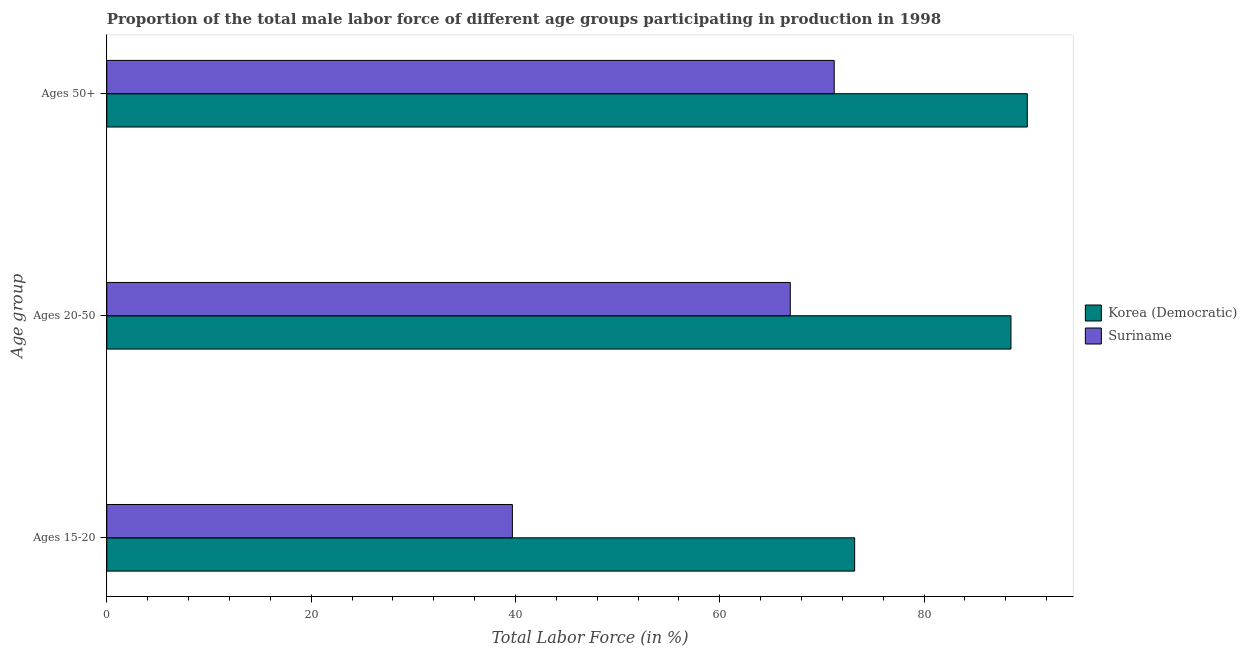Are the number of bars per tick equal to the number of legend labels?
Ensure brevity in your answer.  Yes. Are the number of bars on each tick of the Y-axis equal?
Your answer should be very brief. Yes. How many bars are there on the 3rd tick from the bottom?
Make the answer very short. 2. What is the label of the 2nd group of bars from the top?
Give a very brief answer. Ages 20-50. What is the percentage of male labor force above age 50 in Suriname?
Provide a short and direct response. 71.2. Across all countries, what is the maximum percentage of male labor force within the age group 20-50?
Keep it short and to the point. 88.5. Across all countries, what is the minimum percentage of male labor force within the age group 20-50?
Your answer should be very brief. 66.9. In which country was the percentage of male labor force above age 50 maximum?
Your answer should be compact. Korea (Democratic). In which country was the percentage of male labor force within the age group 15-20 minimum?
Provide a short and direct response. Suriname. What is the total percentage of male labor force within the age group 15-20 in the graph?
Keep it short and to the point. 112.9. What is the difference between the percentage of male labor force within the age group 15-20 in Korea (Democratic) and that in Suriname?
Your response must be concise. 33.5. What is the difference between the percentage of male labor force above age 50 in Suriname and the percentage of male labor force within the age group 20-50 in Korea (Democratic)?
Your answer should be very brief. -17.3. What is the average percentage of male labor force within the age group 15-20 per country?
Provide a succinct answer. 56.45. What is the difference between the percentage of male labor force within the age group 15-20 and percentage of male labor force within the age group 20-50 in Suriname?
Offer a very short reply. -27.2. What is the ratio of the percentage of male labor force above age 50 in Korea (Democratic) to that in Suriname?
Offer a very short reply. 1.27. Is the percentage of male labor force within the age group 15-20 in Suriname less than that in Korea (Democratic)?
Offer a terse response. Yes. What is the difference between the highest and the second highest percentage of male labor force above age 50?
Offer a very short reply. 18.9. What is the difference between the highest and the lowest percentage of male labor force within the age group 15-20?
Ensure brevity in your answer.  33.5. What does the 1st bar from the top in Ages 15-20 represents?
Ensure brevity in your answer.  Suriname. What does the 1st bar from the bottom in Ages 50+ represents?
Provide a short and direct response. Korea (Democratic). How many bars are there?
Your answer should be compact. 6. Are all the bars in the graph horizontal?
Keep it short and to the point. Yes. How many countries are there in the graph?
Your answer should be compact. 2. Are the values on the major ticks of X-axis written in scientific E-notation?
Offer a very short reply. No. Where does the legend appear in the graph?
Keep it short and to the point. Center right. How many legend labels are there?
Your response must be concise. 2. What is the title of the graph?
Provide a short and direct response. Proportion of the total male labor force of different age groups participating in production in 1998. Does "Cuba" appear as one of the legend labels in the graph?
Ensure brevity in your answer.  No. What is the label or title of the X-axis?
Your answer should be very brief. Total Labor Force (in %). What is the label or title of the Y-axis?
Provide a succinct answer. Age group. What is the Total Labor Force (in %) of Korea (Democratic) in Ages 15-20?
Ensure brevity in your answer.  73.2. What is the Total Labor Force (in %) of Suriname in Ages 15-20?
Keep it short and to the point. 39.7. What is the Total Labor Force (in %) of Korea (Democratic) in Ages 20-50?
Offer a terse response. 88.5. What is the Total Labor Force (in %) in Suriname in Ages 20-50?
Give a very brief answer. 66.9. What is the Total Labor Force (in %) in Korea (Democratic) in Ages 50+?
Give a very brief answer. 90.1. What is the Total Labor Force (in %) of Suriname in Ages 50+?
Provide a succinct answer. 71.2. Across all Age group, what is the maximum Total Labor Force (in %) in Korea (Democratic)?
Your answer should be compact. 90.1. Across all Age group, what is the maximum Total Labor Force (in %) of Suriname?
Keep it short and to the point. 71.2. Across all Age group, what is the minimum Total Labor Force (in %) in Korea (Democratic)?
Your answer should be compact. 73.2. Across all Age group, what is the minimum Total Labor Force (in %) of Suriname?
Provide a succinct answer. 39.7. What is the total Total Labor Force (in %) of Korea (Democratic) in the graph?
Make the answer very short. 251.8. What is the total Total Labor Force (in %) in Suriname in the graph?
Keep it short and to the point. 177.8. What is the difference between the Total Labor Force (in %) in Korea (Democratic) in Ages 15-20 and that in Ages 20-50?
Give a very brief answer. -15.3. What is the difference between the Total Labor Force (in %) in Suriname in Ages 15-20 and that in Ages 20-50?
Offer a terse response. -27.2. What is the difference between the Total Labor Force (in %) of Korea (Democratic) in Ages 15-20 and that in Ages 50+?
Ensure brevity in your answer.  -16.9. What is the difference between the Total Labor Force (in %) in Suriname in Ages 15-20 and that in Ages 50+?
Your response must be concise. -31.5. What is the difference between the Total Labor Force (in %) in Korea (Democratic) in Ages 20-50 and that in Ages 50+?
Provide a short and direct response. -1.6. What is the difference between the Total Labor Force (in %) in Suriname in Ages 20-50 and that in Ages 50+?
Provide a short and direct response. -4.3. What is the difference between the Total Labor Force (in %) in Korea (Democratic) in Ages 15-20 and the Total Labor Force (in %) in Suriname in Ages 50+?
Keep it short and to the point. 2. What is the difference between the Total Labor Force (in %) in Korea (Democratic) in Ages 20-50 and the Total Labor Force (in %) in Suriname in Ages 50+?
Ensure brevity in your answer.  17.3. What is the average Total Labor Force (in %) of Korea (Democratic) per Age group?
Your answer should be very brief. 83.93. What is the average Total Labor Force (in %) in Suriname per Age group?
Keep it short and to the point. 59.27. What is the difference between the Total Labor Force (in %) of Korea (Democratic) and Total Labor Force (in %) of Suriname in Ages 15-20?
Offer a terse response. 33.5. What is the difference between the Total Labor Force (in %) in Korea (Democratic) and Total Labor Force (in %) in Suriname in Ages 20-50?
Offer a very short reply. 21.6. What is the ratio of the Total Labor Force (in %) of Korea (Democratic) in Ages 15-20 to that in Ages 20-50?
Your answer should be very brief. 0.83. What is the ratio of the Total Labor Force (in %) of Suriname in Ages 15-20 to that in Ages 20-50?
Ensure brevity in your answer.  0.59. What is the ratio of the Total Labor Force (in %) in Korea (Democratic) in Ages 15-20 to that in Ages 50+?
Provide a short and direct response. 0.81. What is the ratio of the Total Labor Force (in %) of Suriname in Ages 15-20 to that in Ages 50+?
Keep it short and to the point. 0.56. What is the ratio of the Total Labor Force (in %) of Korea (Democratic) in Ages 20-50 to that in Ages 50+?
Your response must be concise. 0.98. What is the ratio of the Total Labor Force (in %) of Suriname in Ages 20-50 to that in Ages 50+?
Ensure brevity in your answer.  0.94. What is the difference between the highest and the lowest Total Labor Force (in %) of Suriname?
Your answer should be very brief. 31.5. 